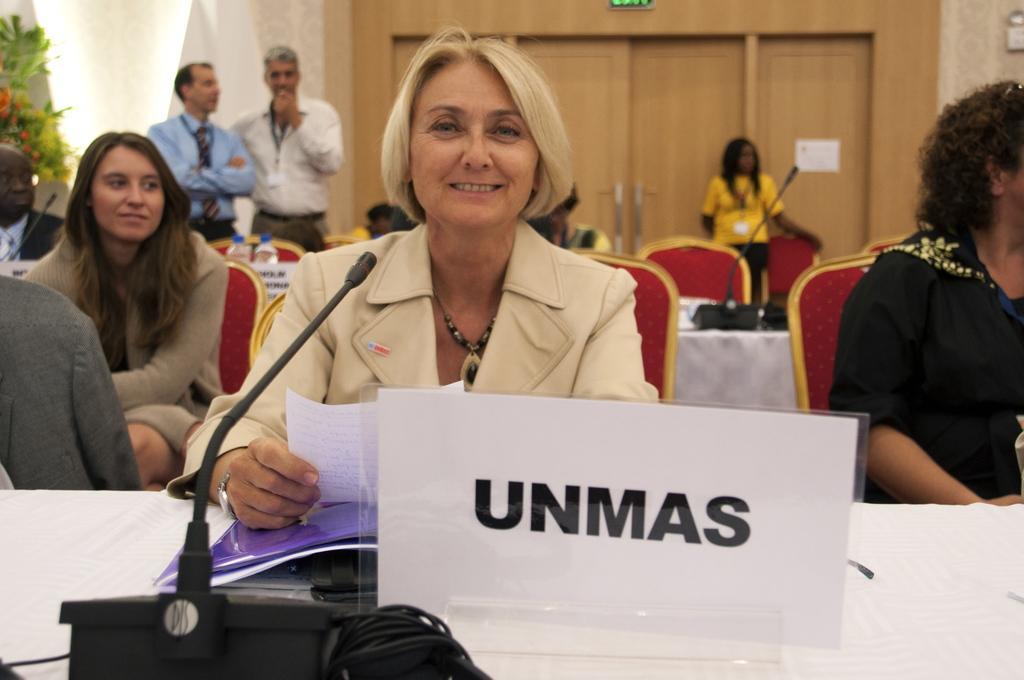Can you describe this image briefly? In this image, we can see a group of people. We can also see some chairs and two water bottles. We can see some tables which are covered with white cloth and some objects on it. There is a door. On the left side, we can see a plant. 